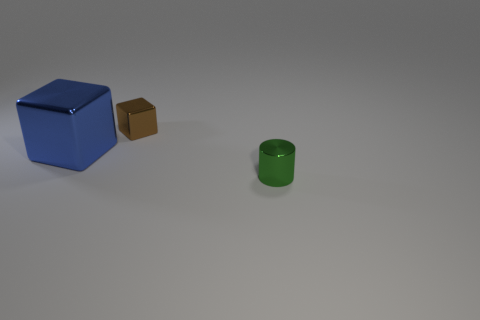What is the material of the tiny object behind the tiny cylinder?
Provide a short and direct response. Metal. Are there any other things that are the same size as the shiny cylinder?
Your answer should be very brief. Yes. Are there any small green cylinders left of the small brown metal thing?
Offer a very short reply. No. What is the shape of the big blue thing?
Offer a very short reply. Cube. What number of things are cubes in front of the small brown block or red metal cylinders?
Your response must be concise. 1. What number of other things are the same color as the big shiny object?
Keep it short and to the point. 0. Is the color of the small cylinder the same as the thing that is behind the big blue cube?
Provide a succinct answer. No. There is another object that is the same shape as the big blue shiny thing; what color is it?
Your response must be concise. Brown. Is the green thing made of the same material as the tiny object that is on the left side of the tiny green metallic cylinder?
Your answer should be compact. Yes. What color is the shiny cylinder?
Offer a very short reply. Green. 